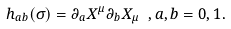<formula> <loc_0><loc_0><loc_500><loc_500>h _ { a b } ( \sigma ) = \partial _ { a } X ^ { \mu } \partial _ { b } X _ { \mu } \ , a , b = 0 , 1 .</formula> 